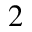Convert formula to latex. <formula><loc_0><loc_0><loc_500><loc_500>_ { 2 }</formula> 